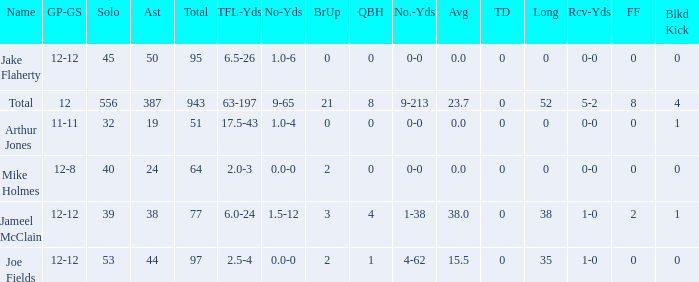What is the total brup for the team? 21.0. 